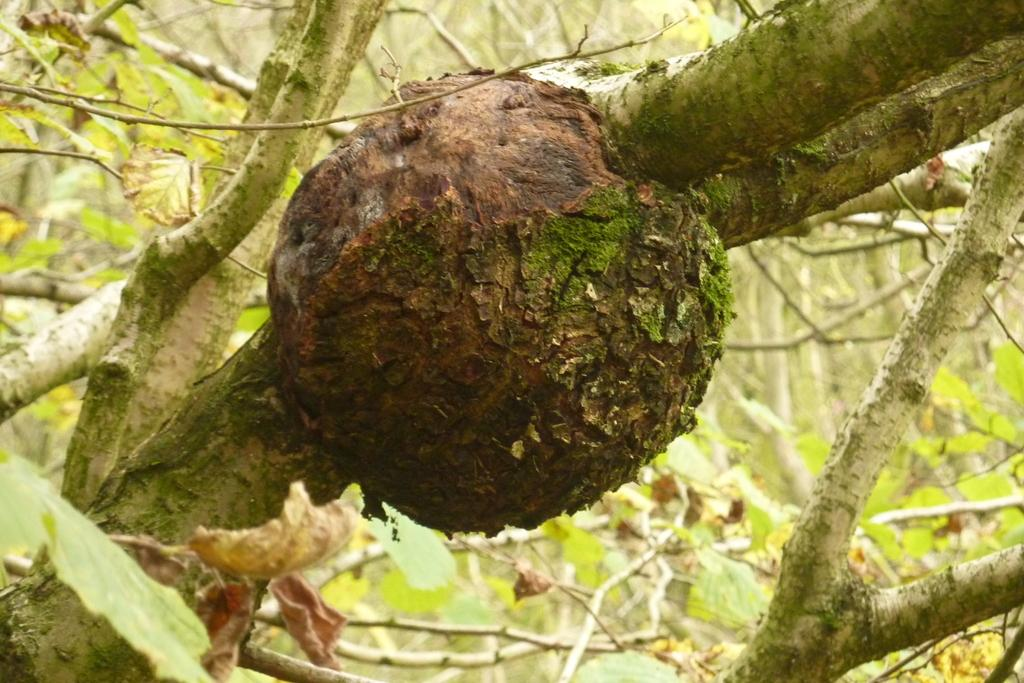What type of vegetation can be seen in the image? There are trees in the image. Can you describe the trees in the image? The provided facts do not include specific details about the trees, so we cannot describe them further. Are there any other objects or subjects visible in the image besides the trees? The provided facts do not mention any other objects or subjects, so we cannot confirm or deny their presence. What type of lunch is being served in the image? There is no mention of lunch or any food items in the provided facts, so we cannot answer this question. 